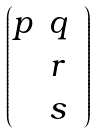<formula> <loc_0><loc_0><loc_500><loc_500>\begin{pmatrix} p & q & \\ & r & \\ & s & \end{pmatrix}</formula> 